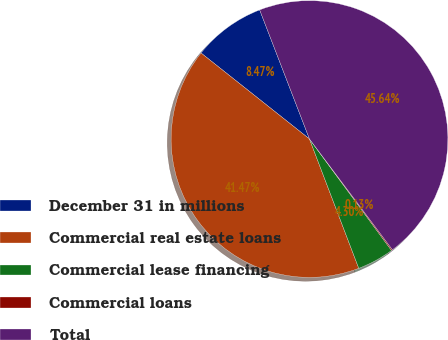Convert chart to OTSL. <chart><loc_0><loc_0><loc_500><loc_500><pie_chart><fcel>December 31 in millions<fcel>Commercial real estate loans<fcel>Commercial lease financing<fcel>Commercial loans<fcel>Total<nl><fcel>8.47%<fcel>41.47%<fcel>4.3%<fcel>0.13%<fcel>45.64%<nl></chart> 